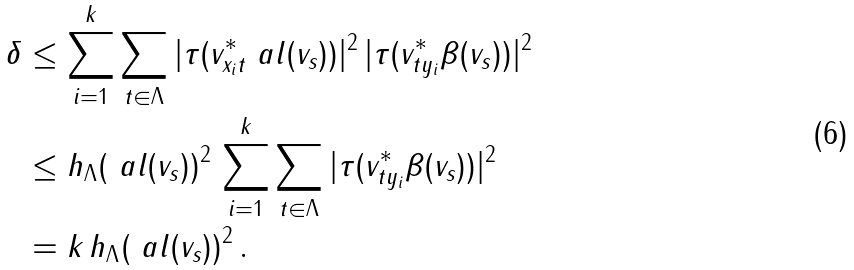<formula> <loc_0><loc_0><loc_500><loc_500>\delta & \leq \sum _ { i = 1 } ^ { k } \sum _ { t \in \Lambda } | \tau ( v _ { x _ { i } t } ^ { * } \ a l ( v _ { s } ) ) | ^ { 2 } \, | \tau ( v _ { t y _ { i } } ^ { * } \beta ( v _ { s } ) ) | ^ { 2 } \\ & \leq h _ { \Lambda } ( \ a l ( v _ { s } ) ) ^ { 2 } \, \sum _ { i = 1 } ^ { k } \sum _ { t \in \Lambda } | \tau ( v _ { t y _ { i } } ^ { * } \beta ( v _ { s } ) ) | ^ { 2 } \\ & = k \, h _ { \Lambda } ( \ a l ( v _ { s } ) ) ^ { 2 } \, .</formula> 